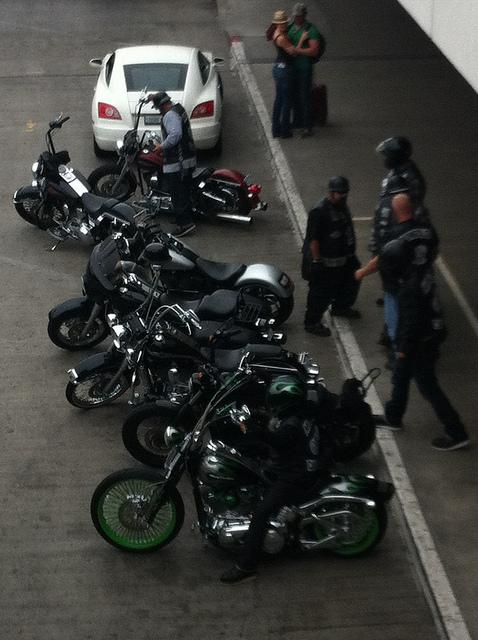What type of vehicle is represented most often in this image?
Be succinct. Motorcycle. Is the motorbike standing in the shade?
Quick response, please. Yes. What is the man holding?
Keep it brief. Handles. What color is their uniform?
Concise answer only. Black. Are they going to the beach?
Answer briefly. No. How many motorcycles are in the photo?
Write a very short answer. 6. What color is the car in the background?
Short answer required. White. What color is the motorcycle pictured in the newspaper?
Keep it brief. Black. Are the vehicles parked in a straight line?
Write a very short answer. No. How many motorbikes?
Answer briefly. 6. What is the make of the motorcycle?
Answer briefly. Harley. 